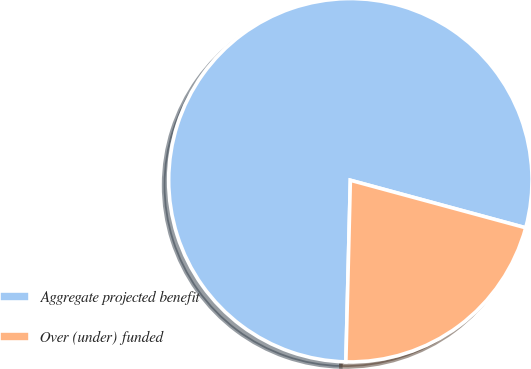<chart> <loc_0><loc_0><loc_500><loc_500><pie_chart><fcel>Aggregate projected benefit<fcel>Over (under) funded<nl><fcel>78.82%<fcel>21.18%<nl></chart> 